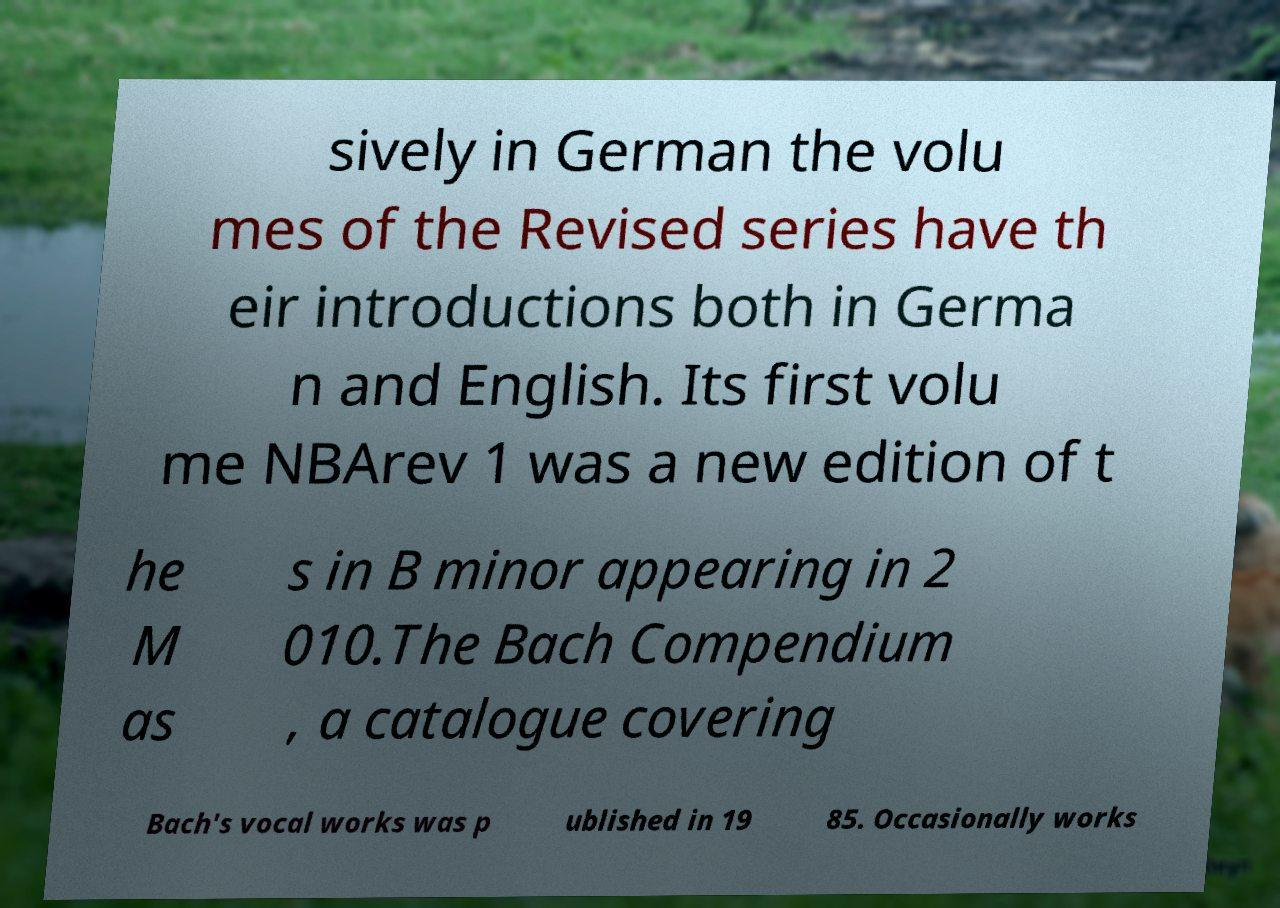Please read and relay the text visible in this image. What does it say? sively in German the volu mes of the Revised series have th eir introductions both in Germa n and English. Its first volu me NBArev 1 was a new edition of t he M as s in B minor appearing in 2 010.The Bach Compendium , a catalogue covering Bach's vocal works was p ublished in 19 85. Occasionally works 